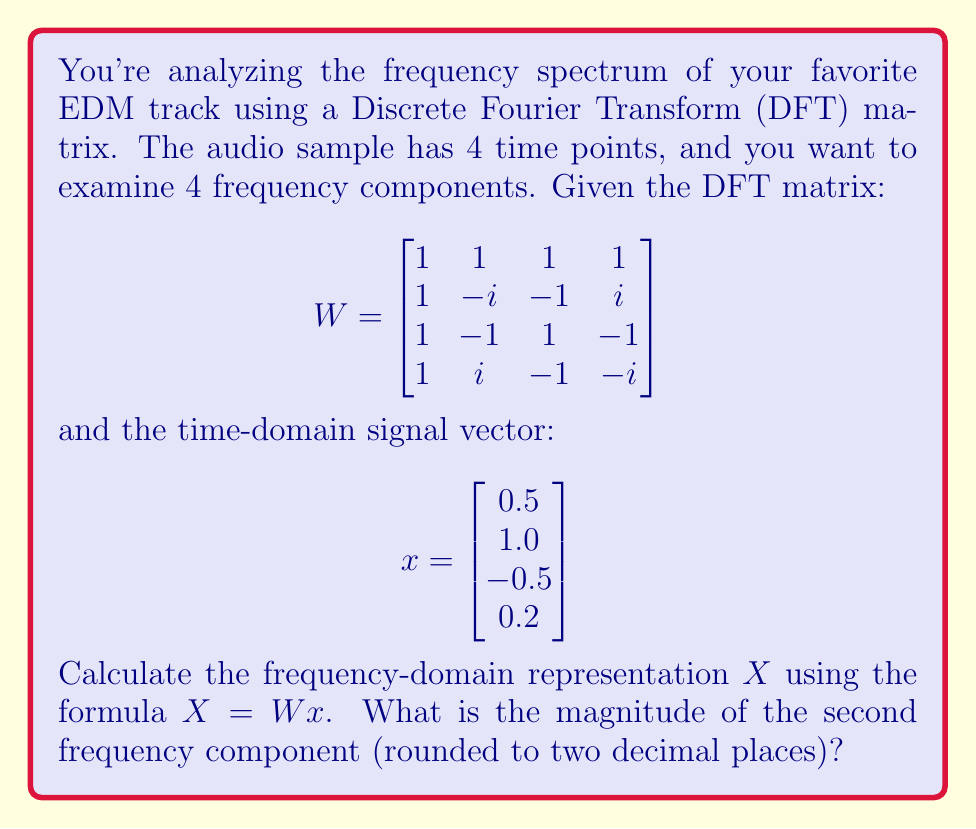Provide a solution to this math problem. Let's approach this step-by-step:

1) We need to multiply the DFT matrix $W$ by the signal vector $x$:

   $$X = Wx = \begin{bmatrix}
   1 & 1 & 1 & 1 \\
   1 & -i & -1 & i \\
   1 & -1 & 1 & -1 \\
   1 & i & -1 & -i
   \end{bmatrix} \begin{bmatrix}
   0.5 \\
   1.0 \\
   -0.5 \\
   0.2
   \end{bmatrix}$$

2) Performing the matrix multiplication:

   $$X = \begin{bmatrix}
   (1 \cdot 0.5) + (1 \cdot 1.0) + (1 \cdot -0.5) + (1 \cdot 0.2) \\
   (1 \cdot 0.5) + (-i \cdot 1.0) + (-1 \cdot -0.5) + (i \cdot 0.2) \\
   (1 \cdot 0.5) + (-1 \cdot 1.0) + (1 \cdot -0.5) + (-1 \cdot 0.2) \\
   (1 \cdot 0.5) + (i \cdot 1.0) + (-1 \cdot -0.5) + (-i \cdot 0.2)
   \end{bmatrix}$$

3) Simplifying:

   $$X = \begin{bmatrix}
   1.2 \\
   0.5 - i + 0.5 + 0.2i \\
   -1.2 \\
   0.5 + i + 0.5 - 0.2i
   \end{bmatrix} = \begin{bmatrix}
   1.2 \\
   1 - 0.8i \\
   -1.2 \\
   1 + 0.8i
   \end{bmatrix}$$

4) The question asks for the magnitude of the second frequency component. This is the magnitude of the complex number $1 - 0.8i$.

5) The magnitude of a complex number $a + bi$ is given by $\sqrt{a^2 + b^2}$.

6) In this case: $\sqrt{1^2 + (-0.8)^2} = \sqrt{1 + 0.64} = \sqrt{1.64} \approx 1.28$

7) Rounding to two decimal places: 1.28
Answer: 1.28 